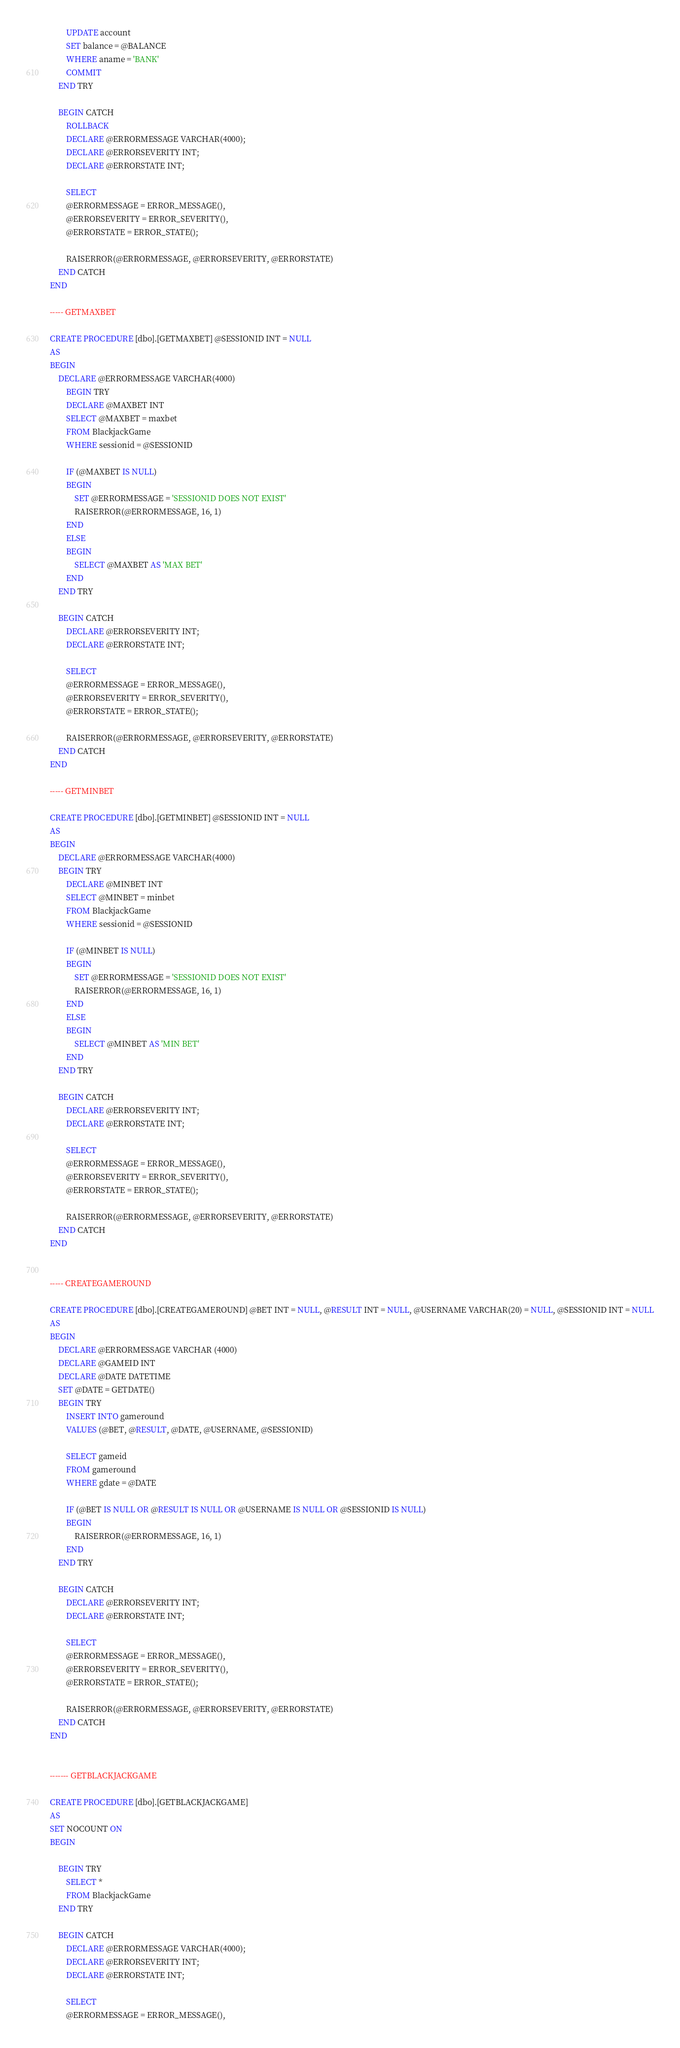<code> <loc_0><loc_0><loc_500><loc_500><_SQL_>		UPDATE account
		SET balance = @BALANCE
		WHERE aname = 'BANK'
		COMMIT
	END TRY

	BEGIN CATCH
		ROLLBACK
		DECLARE @ERRORMESSAGE VARCHAR(4000);
		DECLARE @ERRORSEVERITY INT;
		DECLARE @ERRORSTATE INT;

		SELECT 
		@ERRORMESSAGE = ERROR_MESSAGE(),
		@ERRORSEVERITY = ERROR_SEVERITY(),
		@ERRORSTATE = ERROR_STATE();

		RAISERROR(@ERRORMESSAGE, @ERRORSEVERITY, @ERRORSTATE)
	END CATCH
END

----- GETMAXBET

CREATE PROCEDURE [dbo].[GETMAXBET] @SESSIONID INT = NULL
AS
BEGIN
	DECLARE @ERRORMESSAGE VARCHAR(4000)
		BEGIN TRY
		DECLARE @MAXBET INT
		SELECT @MAXBET = maxbet
		FROM BlackjackGame
		WHERE sessionid = @SESSIONID

		IF (@MAXBET IS NULL)
		BEGIN
			SET @ERRORMESSAGE = 'SESSIONID DOES NOT EXIST'
			RAISERROR(@ERRORMESSAGE, 16, 1)
		END
		ELSE
		BEGIN
			SELECT @MAXBET AS 'MAX BET'
		END
	END TRY

	BEGIN CATCH
		DECLARE @ERRORSEVERITY INT;
		DECLARE @ERRORSTATE INT;

		SELECT 
		@ERRORMESSAGE = ERROR_MESSAGE(),
		@ERRORSEVERITY = ERROR_SEVERITY(),
		@ERRORSTATE = ERROR_STATE();

		RAISERROR(@ERRORMESSAGE, @ERRORSEVERITY, @ERRORSTATE)
	END CATCH
END

----- GETMINBET

CREATE PROCEDURE [dbo].[GETMINBET] @SESSIONID INT = NULL
AS
BEGIN
	DECLARE @ERRORMESSAGE VARCHAR(4000)
	BEGIN TRY
		DECLARE @MINBET INT
		SELECT @MINBET = minbet 
		FROM BlackjackGame
		WHERE sessionid = @SESSIONID

		IF (@MINBET IS NULL)
		BEGIN
			SET @ERRORMESSAGE = 'SESSIONID DOES NOT EXIST'
			RAISERROR(@ERRORMESSAGE, 16, 1)
		END
		ELSE
		BEGIN
			SELECT @MINBET AS 'MIN BET'
		END
	END TRY

	BEGIN CATCH
		DECLARE @ERRORSEVERITY INT;
		DECLARE @ERRORSTATE INT;

		SELECT 
		@ERRORMESSAGE = ERROR_MESSAGE(),
		@ERRORSEVERITY = ERROR_SEVERITY(),
		@ERRORSTATE = ERROR_STATE();

		RAISERROR(@ERRORMESSAGE, @ERRORSEVERITY, @ERRORSTATE)
	END CATCH
END


----- CREATEGAMEROUND

CREATE PROCEDURE [dbo].[CREATEGAMEROUND] @BET INT = NULL, @RESULT INT = NULL, @USERNAME VARCHAR(20) = NULL, @SESSIONID INT = NULL
AS
BEGIN
	DECLARE @ERRORMESSAGE VARCHAR (4000)
	DECLARE @GAMEID INT
	DECLARE @DATE DATETIME
	SET @DATE = GETDATE()
	BEGIN TRY
		INSERT INTO gameround
		VALUES (@BET, @RESULT, @DATE, @USERNAME, @SESSIONID)

		SELECT gameid
		FROM gameround
		WHERE gdate = @DATE

		IF (@BET IS NULL OR @RESULT IS NULL OR @USERNAME IS NULL OR @SESSIONID IS NULL)
		BEGIN
			RAISERROR(@ERRORMESSAGE, 16, 1)
		END
	END TRY

	BEGIN CATCH
		DECLARE @ERRORSEVERITY INT;
		DECLARE @ERRORSTATE INT;

		SELECT 
		@ERRORMESSAGE = ERROR_MESSAGE(),
		@ERRORSEVERITY = ERROR_SEVERITY(),
		@ERRORSTATE = ERROR_STATE();

		RAISERROR(@ERRORMESSAGE, @ERRORSEVERITY, @ERRORSTATE)
	END CATCH
END


------- GETBLACKJACKGAME

CREATE PROCEDURE [dbo].[GETBLACKJACKGAME]
AS
SET NOCOUNT ON
BEGIN

	BEGIN TRY
		SELECT *
		FROM BlackjackGame
	END TRY

	BEGIN CATCH
		DECLARE @ERRORMESSAGE VARCHAR(4000);
		DECLARE @ERRORSEVERITY INT;
		DECLARE @ERRORSTATE INT;

		SELECT 
		@ERRORMESSAGE = ERROR_MESSAGE(),</code> 